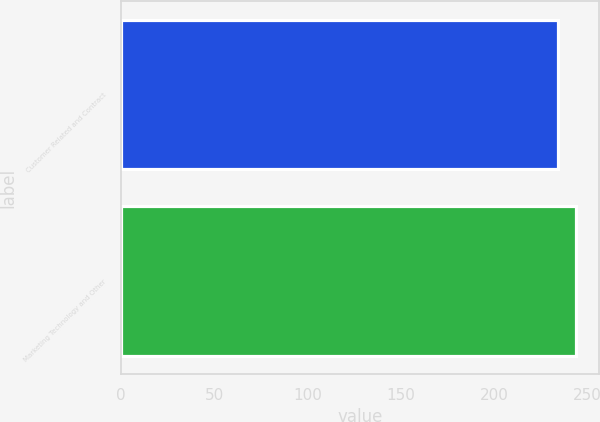Convert chart. <chart><loc_0><loc_0><loc_500><loc_500><bar_chart><fcel>Customer Related and Contract<fcel>Marketing Technology and Other<nl><fcel>234<fcel>244<nl></chart> 